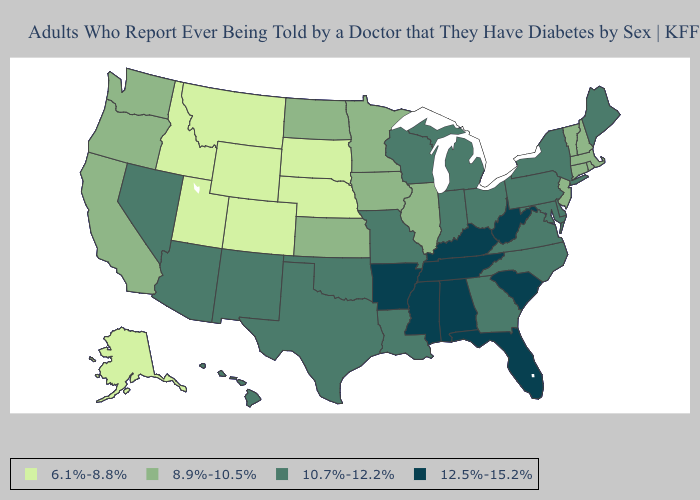What is the highest value in states that border Georgia?
Be succinct. 12.5%-15.2%. Does Massachusetts have the highest value in the USA?
Keep it brief. No. What is the lowest value in the USA?
Write a very short answer. 6.1%-8.8%. Does the map have missing data?
Concise answer only. No. What is the value of Alabama?
Keep it brief. 12.5%-15.2%. Name the states that have a value in the range 8.9%-10.5%?
Be succinct. California, Connecticut, Illinois, Iowa, Kansas, Massachusetts, Minnesota, New Hampshire, New Jersey, North Dakota, Oregon, Rhode Island, Vermont, Washington. Does Colorado have a lower value than Michigan?
Concise answer only. Yes. What is the value of Indiana?
Answer briefly. 10.7%-12.2%. What is the value of Arkansas?
Answer briefly. 12.5%-15.2%. Does New Jersey have a lower value than Maine?
Keep it brief. Yes. Name the states that have a value in the range 6.1%-8.8%?
Answer briefly. Alaska, Colorado, Idaho, Montana, Nebraska, South Dakota, Utah, Wyoming. Which states have the highest value in the USA?
Write a very short answer. Alabama, Arkansas, Florida, Kentucky, Mississippi, South Carolina, Tennessee, West Virginia. Does the map have missing data?
Answer briefly. No. Does the map have missing data?
Answer briefly. No. What is the highest value in the USA?
Answer briefly. 12.5%-15.2%. 